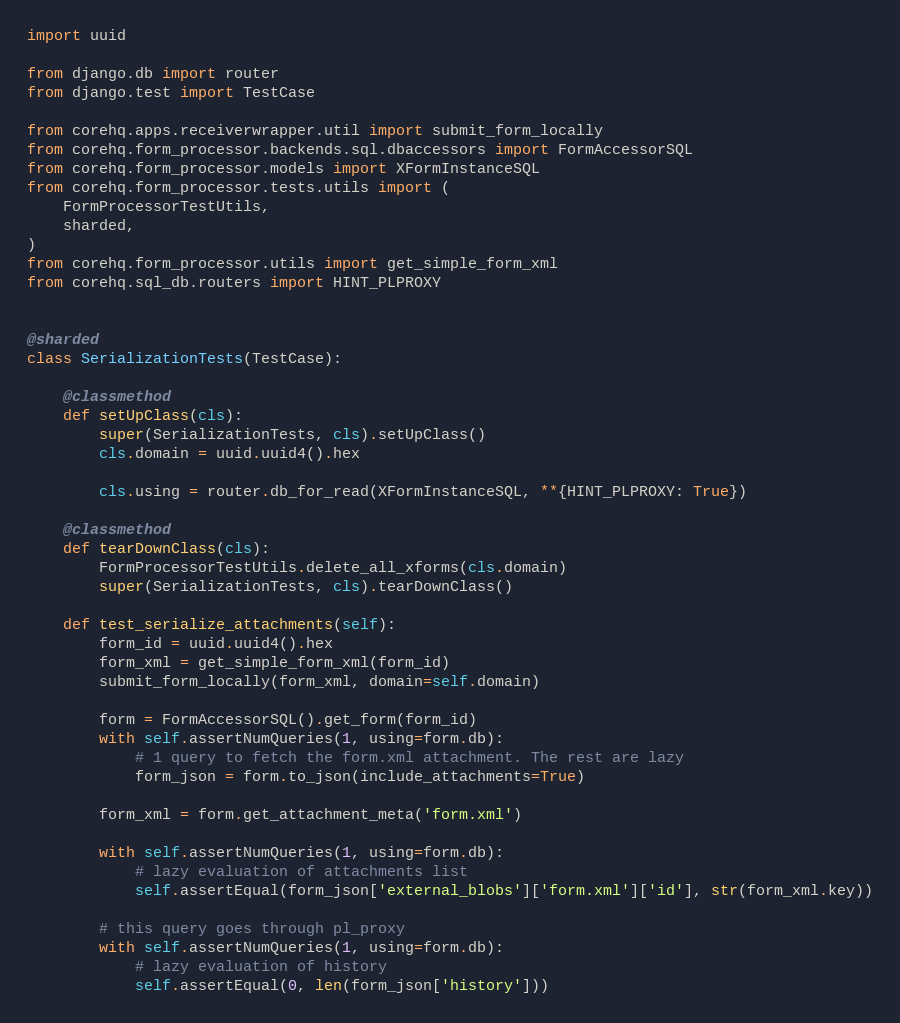Convert code to text. <code><loc_0><loc_0><loc_500><loc_500><_Python_>import uuid

from django.db import router
from django.test import TestCase

from corehq.apps.receiverwrapper.util import submit_form_locally
from corehq.form_processor.backends.sql.dbaccessors import FormAccessorSQL
from corehq.form_processor.models import XFormInstanceSQL
from corehq.form_processor.tests.utils import (
    FormProcessorTestUtils,
    sharded,
)
from corehq.form_processor.utils import get_simple_form_xml
from corehq.sql_db.routers import HINT_PLPROXY


@sharded
class SerializationTests(TestCase):

    @classmethod
    def setUpClass(cls):
        super(SerializationTests, cls).setUpClass()
        cls.domain = uuid.uuid4().hex

        cls.using = router.db_for_read(XFormInstanceSQL, **{HINT_PLPROXY: True})

    @classmethod
    def tearDownClass(cls):
        FormProcessorTestUtils.delete_all_xforms(cls.domain)
        super(SerializationTests, cls).tearDownClass()

    def test_serialize_attachments(self):
        form_id = uuid.uuid4().hex
        form_xml = get_simple_form_xml(form_id)
        submit_form_locally(form_xml, domain=self.domain)

        form = FormAccessorSQL().get_form(form_id)
        with self.assertNumQueries(1, using=form.db):
            # 1 query to fetch the form.xml attachment. The rest are lazy
            form_json = form.to_json(include_attachments=True)

        form_xml = form.get_attachment_meta('form.xml')

        with self.assertNumQueries(1, using=form.db):
            # lazy evaluation of attachments list
            self.assertEqual(form_json['external_blobs']['form.xml']['id'], str(form_xml.key))

        # this query goes through pl_proxy
        with self.assertNumQueries(1, using=form.db):
            # lazy evaluation of history
            self.assertEqual(0, len(form_json['history']))
</code> 